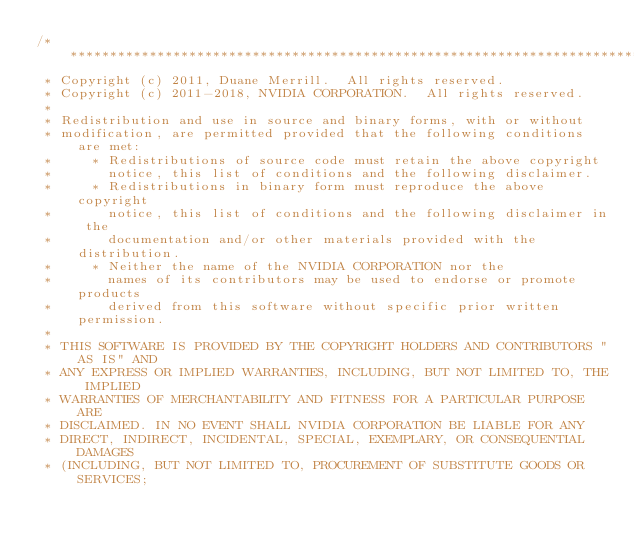Convert code to text. <code><loc_0><loc_0><loc_500><loc_500><_Cuda_>/******************************************************************************
 * Copyright (c) 2011, Duane Merrill.  All rights reserved.
 * Copyright (c) 2011-2018, NVIDIA CORPORATION.  All rights reserved.
 * 
 * Redistribution and use in source and binary forms, with or without
 * modification, are permitted provided that the following conditions are met:
 *     * Redistributions of source code must retain the above copyright
 *       notice, this list of conditions and the following disclaimer.
 *     * Redistributions in binary form must reproduce the above copyright
 *       notice, this list of conditions and the following disclaimer in the
 *       documentation and/or other materials provided with the distribution.
 *     * Neither the name of the NVIDIA CORPORATION nor the
 *       names of its contributors may be used to endorse or promote products
 *       derived from this software without specific prior written permission.
 * 
 * THIS SOFTWARE IS PROVIDED BY THE COPYRIGHT HOLDERS AND CONTRIBUTORS "AS IS" AND
 * ANY EXPRESS OR IMPLIED WARRANTIES, INCLUDING, BUT NOT LIMITED TO, THE IMPLIED
 * WARRANTIES OF MERCHANTABILITY AND FITNESS FOR A PARTICULAR PURPOSE ARE
 * DISCLAIMED. IN NO EVENT SHALL NVIDIA CORPORATION BE LIABLE FOR ANY
 * DIRECT, INDIRECT, INCIDENTAL, SPECIAL, EXEMPLARY, OR CONSEQUENTIAL DAMAGES
 * (INCLUDING, BUT NOT LIMITED TO, PROCUREMENT OF SUBSTITUTE GOODS OR SERVICES;</code> 